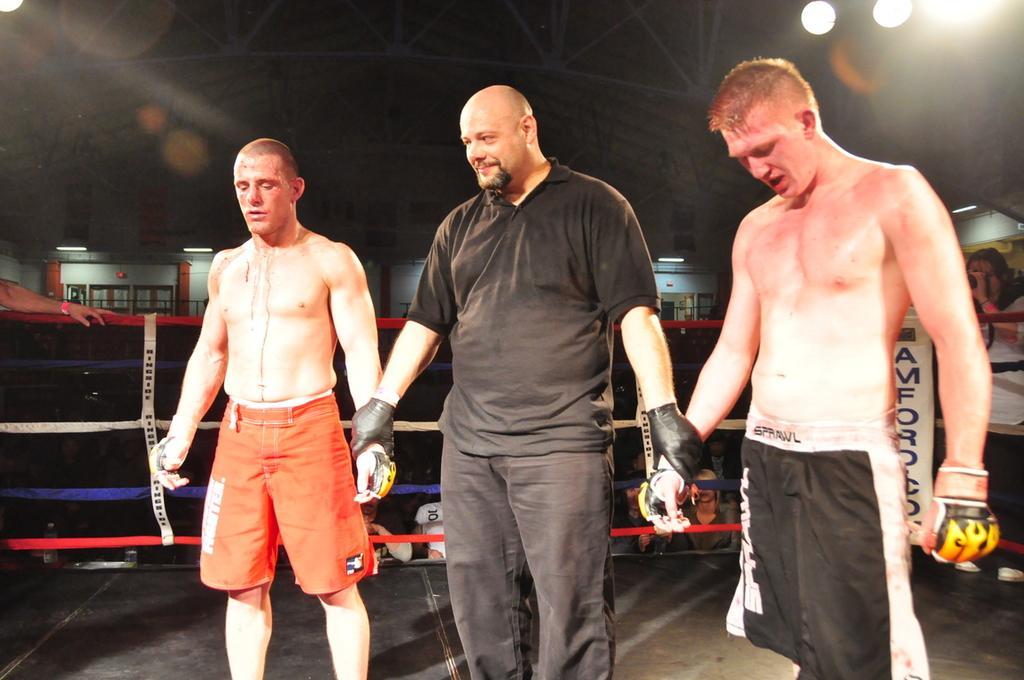How would you summarize this image in a sentence or two? In this picture there are three persons standing. At the back there is a fence and there are group of people and there are windows. On the left side of the image there is a person standing. On the right side of the image there is a person standing and holding the camera. At the top there are lights. 